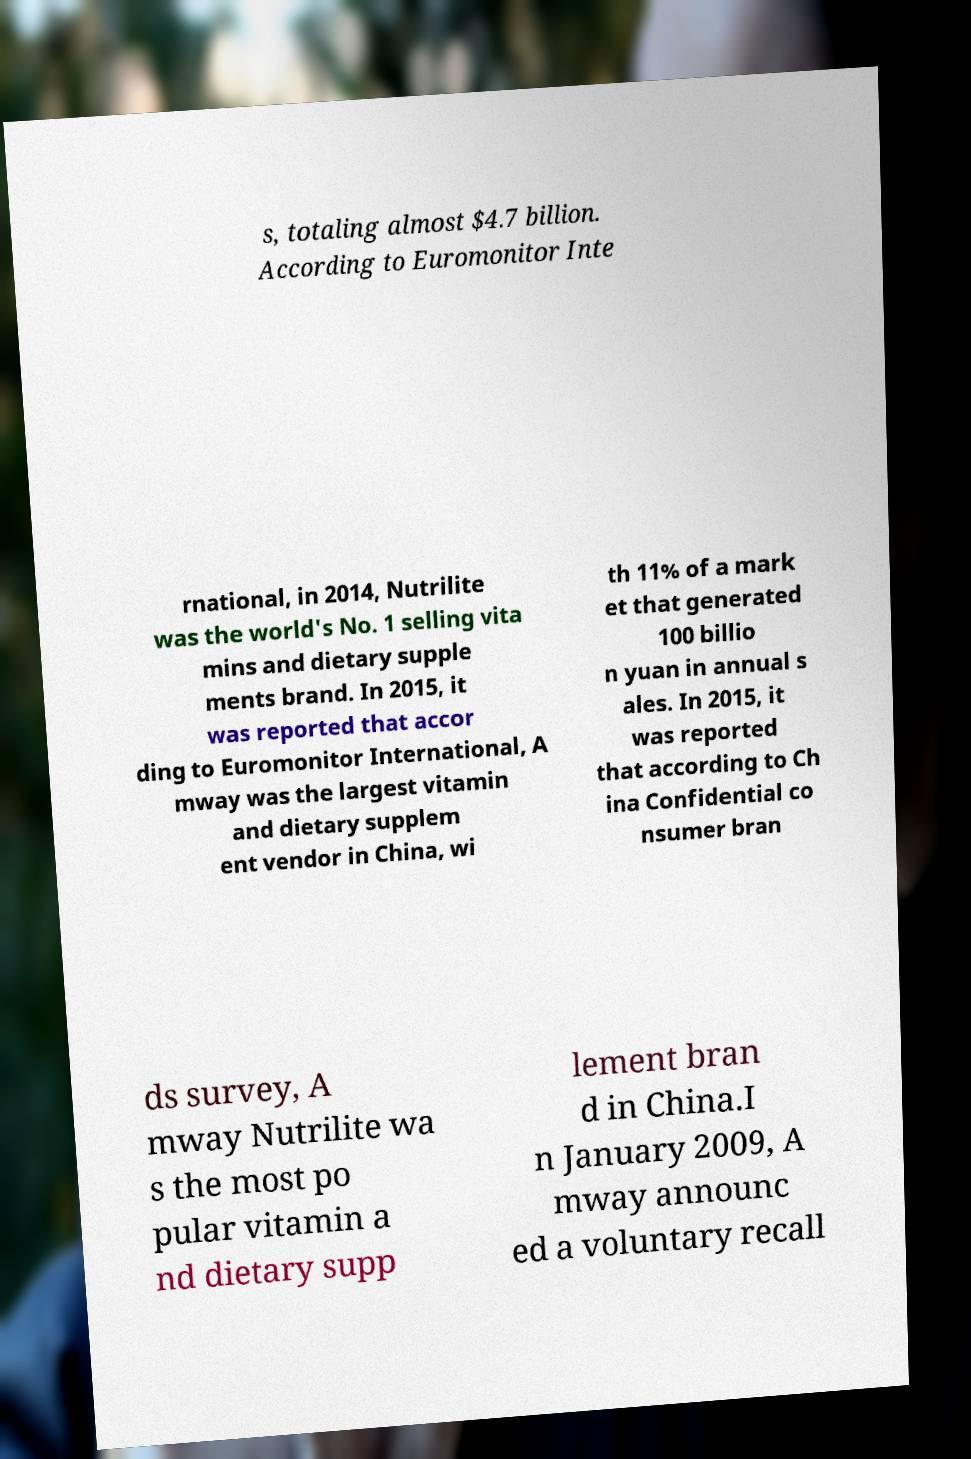Can you accurately transcribe the text from the provided image for me? s, totaling almost $4.7 billion. According to Euromonitor Inte rnational, in 2014, Nutrilite was the world's No. 1 selling vita mins and dietary supple ments brand. In 2015, it was reported that accor ding to Euromonitor International, A mway was the largest vitamin and dietary supplem ent vendor in China, wi th 11% of a mark et that generated 100 billio n yuan in annual s ales. In 2015, it was reported that according to Ch ina Confidential co nsumer bran ds survey, A mway Nutrilite wa s the most po pular vitamin a nd dietary supp lement bran d in China.I n January 2009, A mway announc ed a voluntary recall 